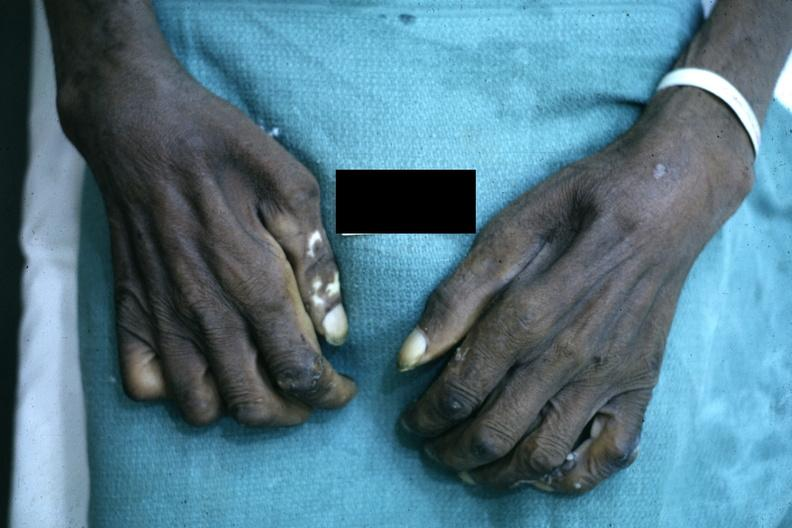s heel ulcer said to be due to syringomyelus?
Answer the question using a single word or phrase. No 